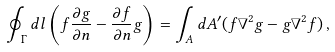<formula> <loc_0><loc_0><loc_500><loc_500>\oint _ { \Gamma } d l \left ( f { \frac { \partial g } { \partial n } } - { \frac { \partial f } { \partial n } } { g } \right ) = \int _ { A } d A ^ { \prime } ( { f } { \nabla } ^ { 2 } { g } - { g } { \nabla } ^ { 2 } { f } ) \, ,</formula> 